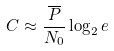Convert formula to latex. <formula><loc_0><loc_0><loc_500><loc_500>C \approx \frac { \overline { P } } { N _ { 0 } } \log _ { 2 } e</formula> 